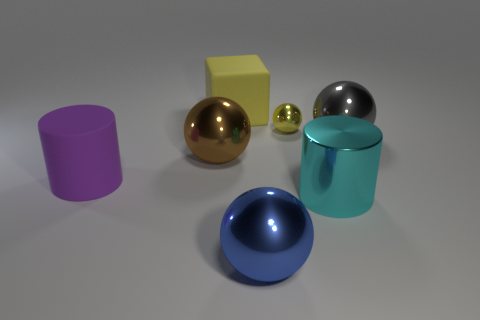Add 3 cyan spheres. How many objects exist? 10 Subtract all cubes. How many objects are left? 6 Add 3 spheres. How many spheres exist? 7 Subtract 1 yellow blocks. How many objects are left? 6 Subtract all large blue objects. Subtract all small gray shiny cubes. How many objects are left? 6 Add 4 tiny yellow balls. How many tiny yellow balls are left? 5 